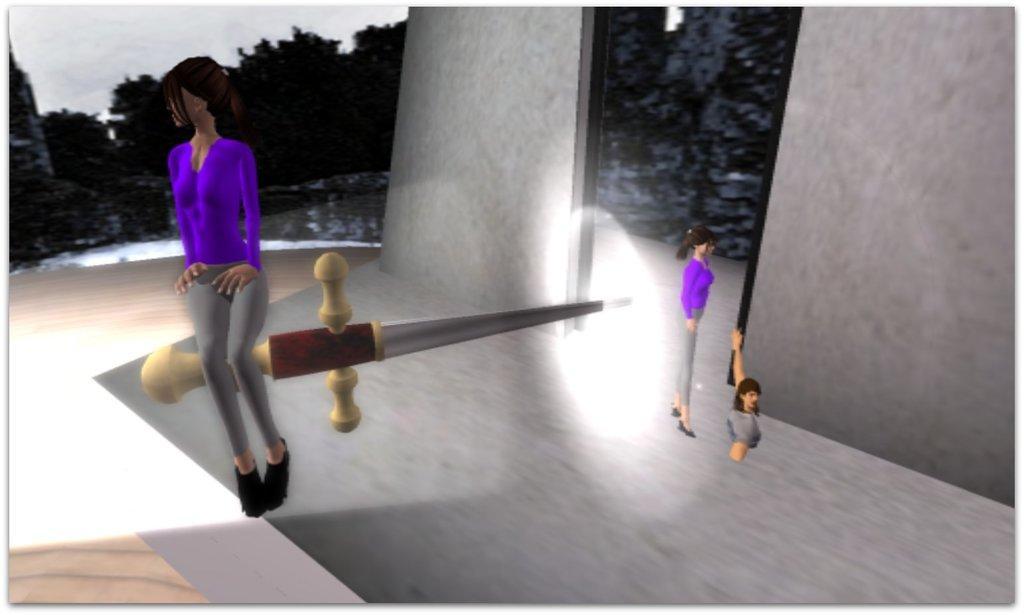Can you describe this image briefly? In the image we can see a graphical images. 